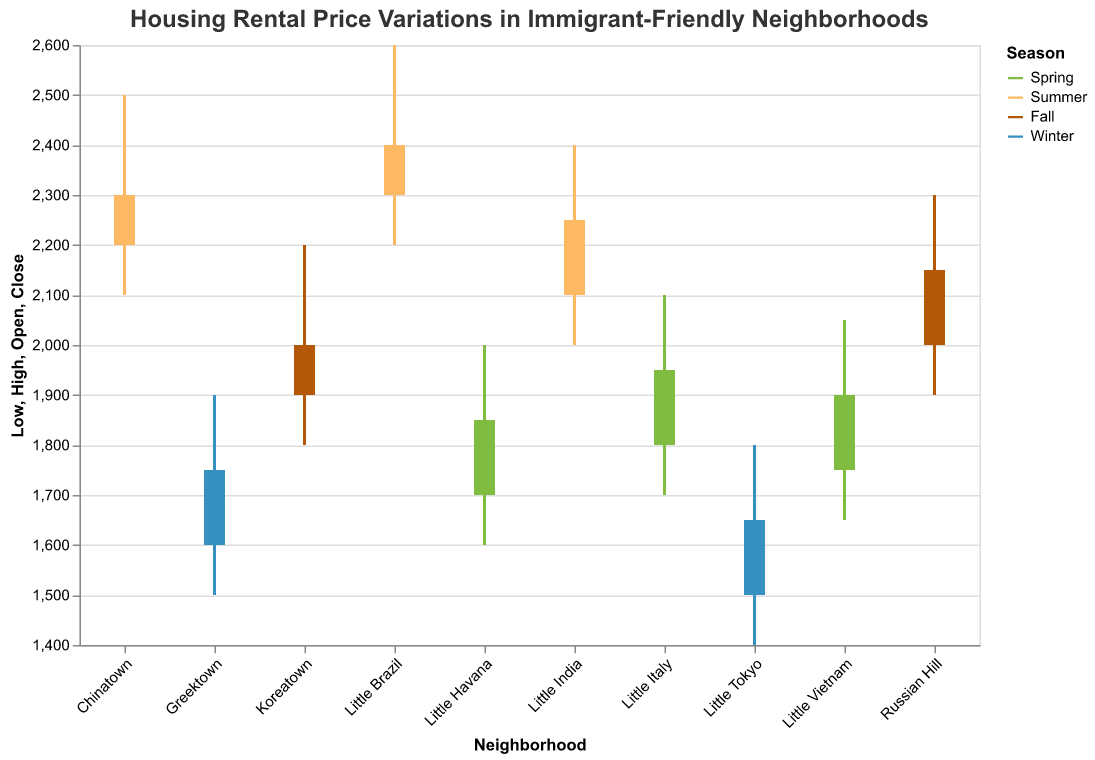What's the title of the chart? The title is located at the top of the chart and usually summarizes what the chart is about. In this case, it reads "Housing Rental Price Variations in Immigrant-Friendly Neighborhoods".
Answer: Housing Rental Price Variations in Immigrant-Friendly Neighborhoods Which season has the most neighborhoods listed in the chart? To answer this, count the number of neighborhoods for each season based on their coloring: Spring, Summer, Fall, and Winter. Spring and Summer each have three neighborhoods, while Fall and Winter each have two.
Answer: Spring and Summer What is the highest rental price observed in the chart, and which neighborhood and season does it belong to? Identify the highest point on the vertical axis among all the bars, which is $2600 in the Summer for Little Brazil.
Answer: Little Brazil in Summer Compare the rental prices between Little Tokyo and Greektown in Winter— which one is higher at the closing price? Look at the "Close" prices in Winter for both neighborhoods: Little Tokyo is $1650, and Greektown is $1750.
Answer: Greektown What is the rental price range for Chinatown in Summer? The range is determined by the highest and lowest prices, which are $2500 and $2100 respectively. Subtracting the lowest from the highest gives the range: $2500 - $2100 = $400.
Answer: $400 How did the rental price in Little Italy change over Spring? The Open price is $1800 and the Close price is $1950. The change is calculated as $1950 - $1800 = $150.
Answer: $150 increase Which season shows the lowest opening rental price and in which neighborhood? Scan the "Open" values for each season. The lowest is in Winter at Little Tokyo with an opening price of $1500.
Answer: Winter in Little Tokyo Identify the neighborhood with the smallest difference between its highest and lowest rental prices. Calculate the difference for each neighborhood by subtracting the lowest price from the highest. The smallest difference is in Little Havana, with highs and lows of $2000 and $1600 respectively: $2000 - $1600 = $400.
Answer: Little Havana Which neighborhood had a higher rental price at the beginning of Fall, Koreatown or Russian Hill? Compare the "Open" price for both neighborhoods in Fall: Koreatown with $1900 and Russian Hill with $2000.
Answer: Russian Hill 